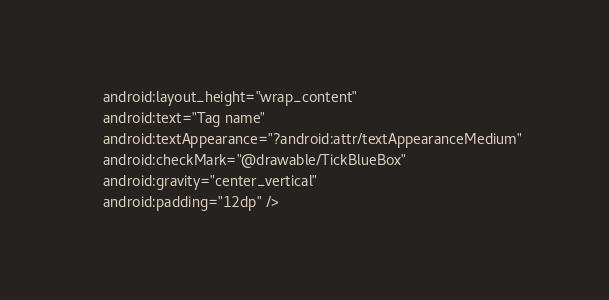<code> <loc_0><loc_0><loc_500><loc_500><_XML_>    android:layout_height="wrap_content"
    android:text="Tag name"
    android:textAppearance="?android:attr/textAppearanceMedium"
    android:checkMark="@drawable/TickBlueBox"
    android:gravity="center_vertical"
    android:padding="12dp" /></code> 